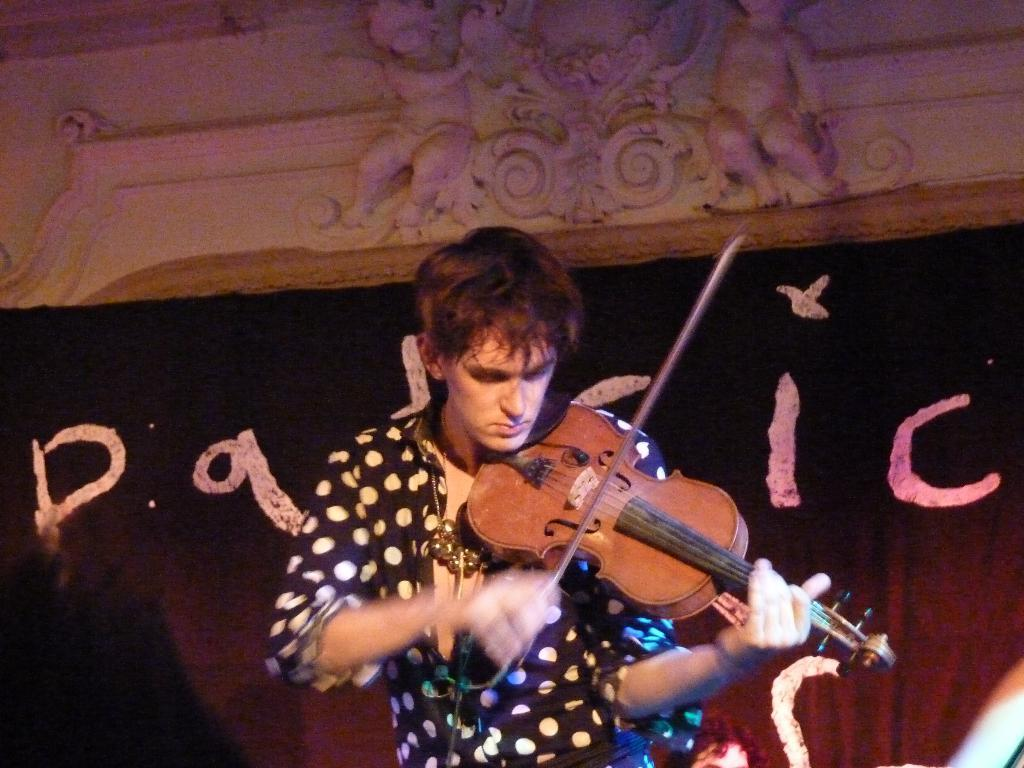What is the man in the image holding? The man is holding a musical instrument. What can be seen in the background of the image? There is a poster and at least one other person in the background of the image. What type of bomb can be seen in the image? There is no bomb present in the image. What kind of tank is visible in the background of the image? There is no tank present in the image. 